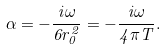Convert formula to latex. <formula><loc_0><loc_0><loc_500><loc_500>\alpha = - \frac { i \omega } { 6 r ^ { 2 } _ { 0 } } = - \frac { i \omega } { 4 \pi T } .</formula> 